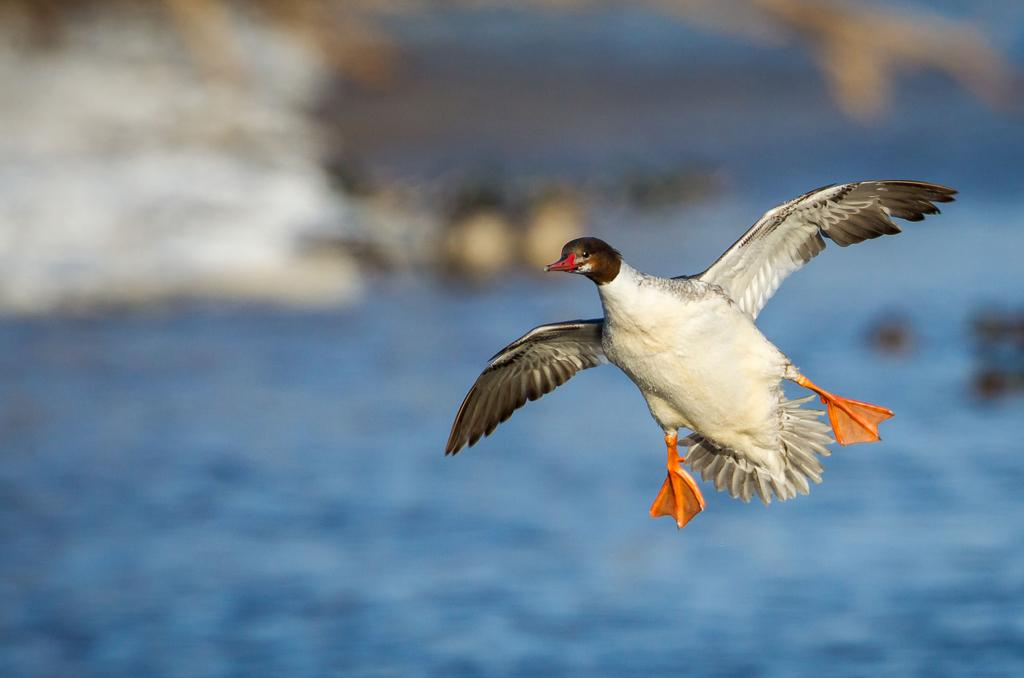What type of animal can be seen in the image? There is a bird in the image. What is the bird doing in the image? The bird is flying. Can you describe the color pattern of the bird? The bird has a color pattern of white, gray, red, and orange. What can be seen in the image besides the bird? There is water visible in the image. How would you describe the background of the image? The background of the image is blurred. Where is the self, lamp, and door located in the image? There is no self, lamp, or door present in the image; it features a bird flying over water with a blurred background. 